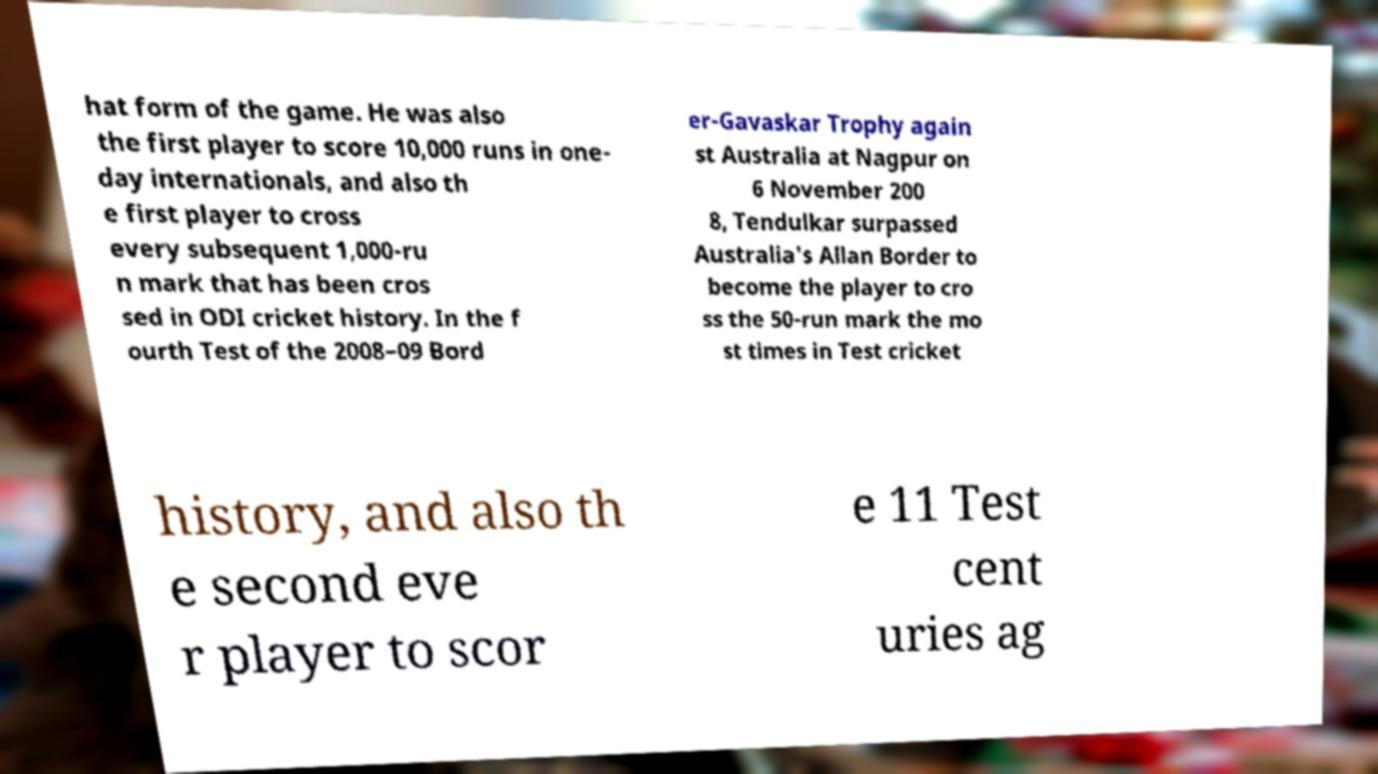Could you assist in decoding the text presented in this image and type it out clearly? hat form of the game. He was also the first player to score 10,000 runs in one- day internationals, and also th e first player to cross every subsequent 1,000-ru n mark that has been cros sed in ODI cricket history. In the f ourth Test of the 2008–09 Bord er-Gavaskar Trophy again st Australia at Nagpur on 6 November 200 8, Tendulkar surpassed Australia's Allan Border to become the player to cro ss the 50-run mark the mo st times in Test cricket history, and also th e second eve r player to scor e 11 Test cent uries ag 